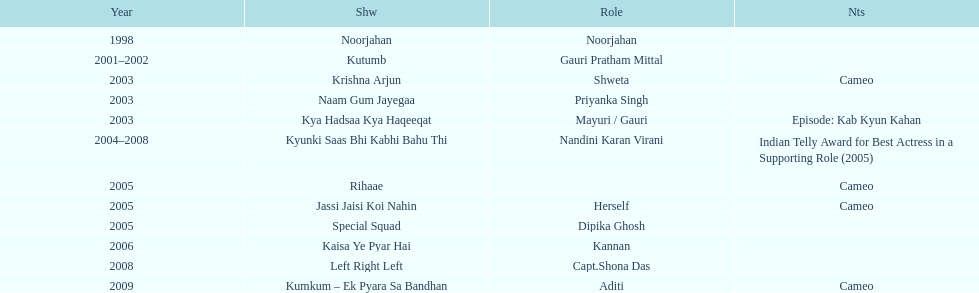Parse the table in full. {'header': ['Year', 'Shw', 'Role', 'Nts'], 'rows': [['1998', 'Noorjahan', 'Noorjahan', ''], ['2001–2002', 'Kutumb', 'Gauri Pratham Mittal', ''], ['2003', 'Krishna Arjun', 'Shweta', 'Cameo'], ['2003', 'Naam Gum Jayegaa', 'Priyanka Singh', ''], ['2003', 'Kya Hadsaa Kya Haqeeqat', 'Mayuri / Gauri', 'Episode: Kab Kyun Kahan'], ['2004–2008', 'Kyunki Saas Bhi Kabhi Bahu Thi', 'Nandini Karan Virani', 'Indian Telly Award for Best Actress in a Supporting Role (2005)'], ['2005', 'Rihaae', '', 'Cameo'], ['2005', 'Jassi Jaisi Koi Nahin', 'Herself', 'Cameo'], ['2005', 'Special Squad', 'Dipika Ghosh', ''], ['2006', 'Kaisa Ye Pyar Hai', 'Kannan', ''], ['2008', 'Left Right Left', 'Capt.Shona Das', ''], ['2009', 'Kumkum – Ek Pyara Sa Bandhan', 'Aditi', 'Cameo']]} The display above left right left Kaisa Ye Pyar Hai. 